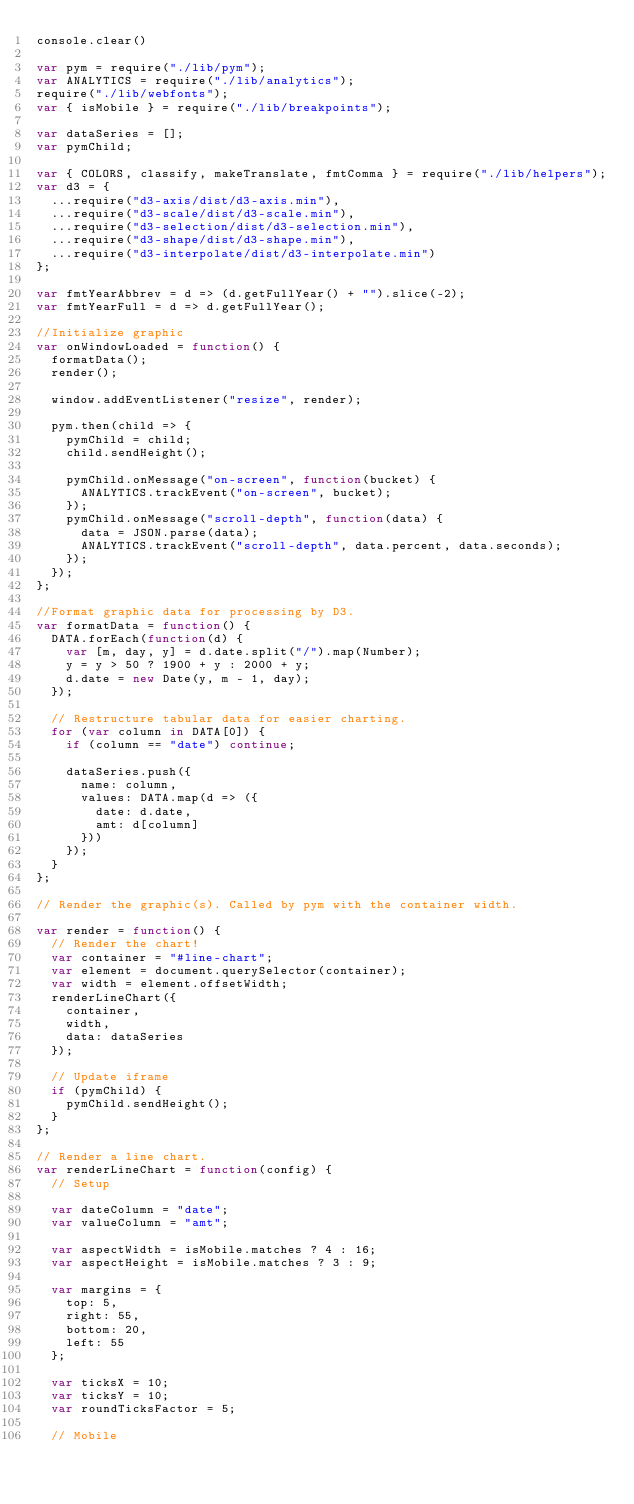Convert code to text. <code><loc_0><loc_0><loc_500><loc_500><_JavaScript_>console.clear()

var pym = require("./lib/pym");
var ANALYTICS = require("./lib/analytics");
require("./lib/webfonts");
var { isMobile } = require("./lib/breakpoints");

var dataSeries = [];
var pymChild;

var { COLORS, classify, makeTranslate, fmtComma } = require("./lib/helpers");
var d3 = {
  ...require("d3-axis/dist/d3-axis.min"),
  ...require("d3-scale/dist/d3-scale.min"),
  ...require("d3-selection/dist/d3-selection.min"),
  ...require("d3-shape/dist/d3-shape.min"),
  ...require("d3-interpolate/dist/d3-interpolate.min")
};

var fmtYearAbbrev = d => (d.getFullYear() + "").slice(-2);
var fmtYearFull = d => d.getFullYear();

//Initialize graphic
var onWindowLoaded = function() {
  formatData();
  render();

  window.addEventListener("resize", render);

  pym.then(child => {
    pymChild = child;
    child.sendHeight();

    pymChild.onMessage("on-screen", function(bucket) {
      ANALYTICS.trackEvent("on-screen", bucket);
    });
    pymChild.onMessage("scroll-depth", function(data) {
      data = JSON.parse(data);
      ANALYTICS.trackEvent("scroll-depth", data.percent, data.seconds);
    });
  });
};

//Format graphic data for processing by D3.
var formatData = function() {
  DATA.forEach(function(d) {
    var [m, day, y] = d.date.split("/").map(Number);
    y = y > 50 ? 1900 + y : 2000 + y;
    d.date = new Date(y, m - 1, day);
  });

  // Restructure tabular data for easier charting.
  for (var column in DATA[0]) {
    if (column == "date") continue;

    dataSeries.push({
      name: column,
      values: DATA.map(d => ({
        date: d.date,
        amt: d[column]
      }))
    });
  }
};

// Render the graphic(s). Called by pym with the container width.

var render = function() {
  // Render the chart!
  var container = "#line-chart";
  var element = document.querySelector(container);
  var width = element.offsetWidth;
  renderLineChart({
    container,
    width,
    data: dataSeries
  });

  // Update iframe
  if (pymChild) {
    pymChild.sendHeight();
  }
};

// Render a line chart.
var renderLineChart = function(config) {
  // Setup

  var dateColumn = "date";
  var valueColumn = "amt";

  var aspectWidth = isMobile.matches ? 4 : 16;
  var aspectHeight = isMobile.matches ? 3 : 9;

  var margins = {
    top: 5,
    right: 55,
    bottom: 20,
    left: 55
  };

  var ticksX = 10;
  var ticksY = 10;
  var roundTicksFactor = 5;

  // Mobile</code> 